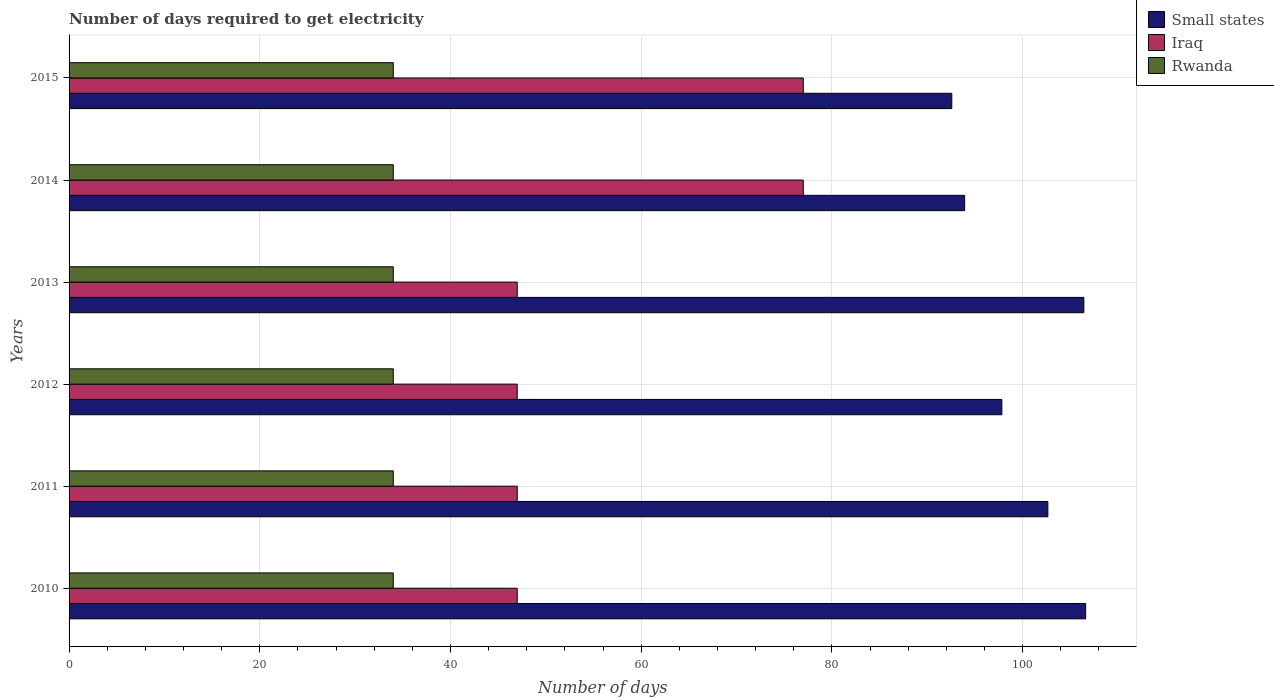Are the number of bars per tick equal to the number of legend labels?
Provide a succinct answer. Yes. Are the number of bars on each tick of the Y-axis equal?
Your answer should be very brief. Yes. What is the label of the 3rd group of bars from the top?
Offer a terse response. 2013. In how many cases, is the number of bars for a given year not equal to the number of legend labels?
Provide a succinct answer. 0. What is the number of days required to get electricity in in Small states in 2015?
Ensure brevity in your answer.  92.58. Across all years, what is the maximum number of days required to get electricity in in Rwanda?
Ensure brevity in your answer.  34. Across all years, what is the minimum number of days required to get electricity in in Rwanda?
Offer a terse response. 34. In which year was the number of days required to get electricity in in Iraq maximum?
Offer a terse response. 2014. What is the total number of days required to get electricity in in Rwanda in the graph?
Your response must be concise. 204. What is the difference between the number of days required to get electricity in in Small states in 2011 and that in 2013?
Provide a short and direct response. -3.77. What is the difference between the number of days required to get electricity in in Rwanda in 2013 and the number of days required to get electricity in in Iraq in 2015?
Your response must be concise. -43. In the year 2011, what is the difference between the number of days required to get electricity in in Iraq and number of days required to get electricity in in Small states?
Your answer should be very brief. -55.65. What is the ratio of the number of days required to get electricity in in Rwanda in 2010 to that in 2013?
Provide a short and direct response. 1. What is the difference between the highest and the second highest number of days required to get electricity in in Small states?
Provide a short and direct response. 0.19. What is the difference between the highest and the lowest number of days required to get electricity in in Iraq?
Make the answer very short. 30. In how many years, is the number of days required to get electricity in in Iraq greater than the average number of days required to get electricity in in Iraq taken over all years?
Your answer should be compact. 2. What does the 1st bar from the top in 2013 represents?
Keep it short and to the point. Rwanda. What does the 3rd bar from the bottom in 2010 represents?
Provide a short and direct response. Rwanda. Is it the case that in every year, the sum of the number of days required to get electricity in in Rwanda and number of days required to get electricity in in Iraq is greater than the number of days required to get electricity in in Small states?
Your answer should be very brief. No. How many years are there in the graph?
Your response must be concise. 6. Are the values on the major ticks of X-axis written in scientific E-notation?
Provide a succinct answer. No. Where does the legend appear in the graph?
Keep it short and to the point. Top right. How many legend labels are there?
Keep it short and to the point. 3. What is the title of the graph?
Your answer should be compact. Number of days required to get electricity. Does "Greece" appear as one of the legend labels in the graph?
Offer a very short reply. No. What is the label or title of the X-axis?
Your answer should be very brief. Number of days. What is the label or title of the Y-axis?
Your answer should be compact. Years. What is the Number of days in Small states in 2010?
Keep it short and to the point. 106.62. What is the Number of days in Iraq in 2010?
Provide a short and direct response. 47. What is the Number of days of Rwanda in 2010?
Offer a terse response. 34. What is the Number of days of Small states in 2011?
Give a very brief answer. 102.65. What is the Number of days in Iraq in 2011?
Your answer should be compact. 47. What is the Number of days of Rwanda in 2011?
Provide a succinct answer. 34. What is the Number of days of Small states in 2012?
Your answer should be compact. 97.83. What is the Number of days of Rwanda in 2012?
Make the answer very short. 34. What is the Number of days in Small states in 2013?
Your answer should be very brief. 106.42. What is the Number of days in Small states in 2014?
Provide a succinct answer. 93.92. What is the Number of days in Iraq in 2014?
Make the answer very short. 77. What is the Number of days of Small states in 2015?
Your response must be concise. 92.58. What is the Number of days of Iraq in 2015?
Your answer should be compact. 77. What is the Number of days of Rwanda in 2015?
Provide a short and direct response. 34. Across all years, what is the maximum Number of days in Small states?
Your answer should be compact. 106.62. Across all years, what is the maximum Number of days in Iraq?
Your answer should be very brief. 77. Across all years, what is the minimum Number of days in Small states?
Your answer should be very brief. 92.58. Across all years, what is the minimum Number of days in Iraq?
Your response must be concise. 47. Across all years, what is the minimum Number of days of Rwanda?
Your answer should be compact. 34. What is the total Number of days of Small states in the graph?
Ensure brevity in your answer.  600.02. What is the total Number of days of Iraq in the graph?
Give a very brief answer. 342. What is the total Number of days in Rwanda in the graph?
Give a very brief answer. 204. What is the difference between the Number of days of Small states in 2010 and that in 2011?
Provide a short and direct response. 3.97. What is the difference between the Number of days in Iraq in 2010 and that in 2011?
Give a very brief answer. 0. What is the difference between the Number of days of Small states in 2010 and that in 2012?
Offer a very short reply. 8.79. What is the difference between the Number of days of Rwanda in 2010 and that in 2012?
Offer a very short reply. 0. What is the difference between the Number of days in Small states in 2010 and that in 2013?
Provide a short and direct response. 0.19. What is the difference between the Number of days of Rwanda in 2010 and that in 2013?
Make the answer very short. 0. What is the difference between the Number of days in Small states in 2010 and that in 2014?
Ensure brevity in your answer.  12.69. What is the difference between the Number of days in Iraq in 2010 and that in 2014?
Offer a very short reply. -30. What is the difference between the Number of days of Rwanda in 2010 and that in 2014?
Provide a short and direct response. 0. What is the difference between the Number of days in Small states in 2010 and that in 2015?
Keep it short and to the point. 14.04. What is the difference between the Number of days in Small states in 2011 and that in 2012?
Provide a short and direct response. 4.83. What is the difference between the Number of days of Small states in 2011 and that in 2013?
Provide a succinct answer. -3.77. What is the difference between the Number of days of Rwanda in 2011 and that in 2013?
Offer a very short reply. 0. What is the difference between the Number of days of Small states in 2011 and that in 2014?
Keep it short and to the point. 8.72. What is the difference between the Number of days of Small states in 2011 and that in 2015?
Give a very brief answer. 10.07. What is the difference between the Number of days of Rwanda in 2011 and that in 2015?
Offer a terse response. 0. What is the difference between the Number of days of Small states in 2012 and that in 2013?
Give a very brief answer. -8.6. What is the difference between the Number of days of Iraq in 2012 and that in 2013?
Ensure brevity in your answer.  0. What is the difference between the Number of days in Rwanda in 2012 and that in 2014?
Provide a succinct answer. 0. What is the difference between the Number of days of Small states in 2012 and that in 2015?
Provide a short and direct response. 5.25. What is the difference between the Number of days of Iraq in 2012 and that in 2015?
Ensure brevity in your answer.  -30. What is the difference between the Number of days of Small states in 2013 and that in 2014?
Offer a terse response. 12.5. What is the difference between the Number of days of Iraq in 2013 and that in 2014?
Give a very brief answer. -30. What is the difference between the Number of days of Small states in 2013 and that in 2015?
Offer a very short reply. 13.85. What is the difference between the Number of days in Small states in 2014 and that in 2015?
Provide a short and direct response. 1.35. What is the difference between the Number of days of Iraq in 2014 and that in 2015?
Keep it short and to the point. 0. What is the difference between the Number of days of Small states in 2010 and the Number of days of Iraq in 2011?
Offer a terse response. 59.62. What is the difference between the Number of days of Small states in 2010 and the Number of days of Rwanda in 2011?
Offer a very short reply. 72.62. What is the difference between the Number of days of Small states in 2010 and the Number of days of Iraq in 2012?
Your answer should be compact. 59.62. What is the difference between the Number of days in Small states in 2010 and the Number of days in Rwanda in 2012?
Provide a succinct answer. 72.62. What is the difference between the Number of days of Iraq in 2010 and the Number of days of Rwanda in 2012?
Provide a short and direct response. 13. What is the difference between the Number of days of Small states in 2010 and the Number of days of Iraq in 2013?
Offer a terse response. 59.62. What is the difference between the Number of days in Small states in 2010 and the Number of days in Rwanda in 2013?
Provide a succinct answer. 72.62. What is the difference between the Number of days in Iraq in 2010 and the Number of days in Rwanda in 2013?
Your answer should be very brief. 13. What is the difference between the Number of days of Small states in 2010 and the Number of days of Iraq in 2014?
Your answer should be very brief. 29.62. What is the difference between the Number of days in Small states in 2010 and the Number of days in Rwanda in 2014?
Ensure brevity in your answer.  72.62. What is the difference between the Number of days of Iraq in 2010 and the Number of days of Rwanda in 2014?
Ensure brevity in your answer.  13. What is the difference between the Number of days of Small states in 2010 and the Number of days of Iraq in 2015?
Give a very brief answer. 29.62. What is the difference between the Number of days of Small states in 2010 and the Number of days of Rwanda in 2015?
Give a very brief answer. 72.62. What is the difference between the Number of days of Small states in 2011 and the Number of days of Iraq in 2012?
Give a very brief answer. 55.65. What is the difference between the Number of days in Small states in 2011 and the Number of days in Rwanda in 2012?
Keep it short and to the point. 68.65. What is the difference between the Number of days of Small states in 2011 and the Number of days of Iraq in 2013?
Offer a terse response. 55.65. What is the difference between the Number of days of Small states in 2011 and the Number of days of Rwanda in 2013?
Give a very brief answer. 68.65. What is the difference between the Number of days in Small states in 2011 and the Number of days in Iraq in 2014?
Keep it short and to the point. 25.65. What is the difference between the Number of days of Small states in 2011 and the Number of days of Rwanda in 2014?
Your answer should be very brief. 68.65. What is the difference between the Number of days in Iraq in 2011 and the Number of days in Rwanda in 2014?
Give a very brief answer. 13. What is the difference between the Number of days of Small states in 2011 and the Number of days of Iraq in 2015?
Make the answer very short. 25.65. What is the difference between the Number of days in Small states in 2011 and the Number of days in Rwanda in 2015?
Provide a short and direct response. 68.65. What is the difference between the Number of days in Iraq in 2011 and the Number of days in Rwanda in 2015?
Offer a very short reply. 13. What is the difference between the Number of days of Small states in 2012 and the Number of days of Iraq in 2013?
Your answer should be compact. 50.83. What is the difference between the Number of days of Small states in 2012 and the Number of days of Rwanda in 2013?
Ensure brevity in your answer.  63.83. What is the difference between the Number of days of Iraq in 2012 and the Number of days of Rwanda in 2013?
Give a very brief answer. 13. What is the difference between the Number of days of Small states in 2012 and the Number of days of Iraq in 2014?
Make the answer very short. 20.82. What is the difference between the Number of days of Small states in 2012 and the Number of days of Rwanda in 2014?
Your response must be concise. 63.83. What is the difference between the Number of days of Iraq in 2012 and the Number of days of Rwanda in 2014?
Offer a terse response. 13. What is the difference between the Number of days of Small states in 2012 and the Number of days of Iraq in 2015?
Your response must be concise. 20.82. What is the difference between the Number of days in Small states in 2012 and the Number of days in Rwanda in 2015?
Your answer should be compact. 63.83. What is the difference between the Number of days in Iraq in 2012 and the Number of days in Rwanda in 2015?
Make the answer very short. 13. What is the difference between the Number of days of Small states in 2013 and the Number of days of Iraq in 2014?
Provide a succinct answer. 29.43. What is the difference between the Number of days of Small states in 2013 and the Number of days of Rwanda in 2014?
Ensure brevity in your answer.  72.42. What is the difference between the Number of days in Iraq in 2013 and the Number of days in Rwanda in 2014?
Your answer should be compact. 13. What is the difference between the Number of days of Small states in 2013 and the Number of days of Iraq in 2015?
Your answer should be very brief. 29.43. What is the difference between the Number of days in Small states in 2013 and the Number of days in Rwanda in 2015?
Ensure brevity in your answer.  72.42. What is the difference between the Number of days in Iraq in 2013 and the Number of days in Rwanda in 2015?
Your answer should be compact. 13. What is the difference between the Number of days of Small states in 2014 and the Number of days of Iraq in 2015?
Provide a succinct answer. 16.93. What is the difference between the Number of days of Small states in 2014 and the Number of days of Rwanda in 2015?
Offer a very short reply. 59.92. What is the difference between the Number of days in Iraq in 2014 and the Number of days in Rwanda in 2015?
Your answer should be very brief. 43. What is the average Number of days in Small states per year?
Your answer should be compact. 100. In the year 2010, what is the difference between the Number of days of Small states and Number of days of Iraq?
Ensure brevity in your answer.  59.62. In the year 2010, what is the difference between the Number of days of Small states and Number of days of Rwanda?
Keep it short and to the point. 72.62. In the year 2010, what is the difference between the Number of days of Iraq and Number of days of Rwanda?
Your answer should be compact. 13. In the year 2011, what is the difference between the Number of days in Small states and Number of days in Iraq?
Your answer should be compact. 55.65. In the year 2011, what is the difference between the Number of days in Small states and Number of days in Rwanda?
Make the answer very short. 68.65. In the year 2011, what is the difference between the Number of days in Iraq and Number of days in Rwanda?
Provide a short and direct response. 13. In the year 2012, what is the difference between the Number of days in Small states and Number of days in Iraq?
Your response must be concise. 50.83. In the year 2012, what is the difference between the Number of days in Small states and Number of days in Rwanda?
Keep it short and to the point. 63.83. In the year 2012, what is the difference between the Number of days in Iraq and Number of days in Rwanda?
Keep it short and to the point. 13. In the year 2013, what is the difference between the Number of days in Small states and Number of days in Iraq?
Make the answer very short. 59.42. In the year 2013, what is the difference between the Number of days in Small states and Number of days in Rwanda?
Offer a very short reply. 72.42. In the year 2013, what is the difference between the Number of days in Iraq and Number of days in Rwanda?
Provide a short and direct response. 13. In the year 2014, what is the difference between the Number of days in Small states and Number of days in Iraq?
Your answer should be compact. 16.93. In the year 2014, what is the difference between the Number of days in Small states and Number of days in Rwanda?
Make the answer very short. 59.92. In the year 2015, what is the difference between the Number of days in Small states and Number of days in Iraq?
Provide a succinct answer. 15.57. In the year 2015, what is the difference between the Number of days of Small states and Number of days of Rwanda?
Ensure brevity in your answer.  58.58. In the year 2015, what is the difference between the Number of days of Iraq and Number of days of Rwanda?
Ensure brevity in your answer.  43. What is the ratio of the Number of days of Small states in 2010 to that in 2011?
Make the answer very short. 1.04. What is the ratio of the Number of days in Small states in 2010 to that in 2012?
Offer a terse response. 1.09. What is the ratio of the Number of days in Iraq in 2010 to that in 2012?
Your answer should be compact. 1. What is the ratio of the Number of days of Iraq in 2010 to that in 2013?
Your answer should be compact. 1. What is the ratio of the Number of days in Rwanda in 2010 to that in 2013?
Keep it short and to the point. 1. What is the ratio of the Number of days in Small states in 2010 to that in 2014?
Provide a short and direct response. 1.14. What is the ratio of the Number of days in Iraq in 2010 to that in 2014?
Make the answer very short. 0.61. What is the ratio of the Number of days of Small states in 2010 to that in 2015?
Offer a very short reply. 1.15. What is the ratio of the Number of days in Iraq in 2010 to that in 2015?
Your response must be concise. 0.61. What is the ratio of the Number of days of Small states in 2011 to that in 2012?
Offer a very short reply. 1.05. What is the ratio of the Number of days in Rwanda in 2011 to that in 2012?
Your response must be concise. 1. What is the ratio of the Number of days of Small states in 2011 to that in 2013?
Keep it short and to the point. 0.96. What is the ratio of the Number of days in Iraq in 2011 to that in 2013?
Give a very brief answer. 1. What is the ratio of the Number of days of Small states in 2011 to that in 2014?
Your answer should be compact. 1.09. What is the ratio of the Number of days of Iraq in 2011 to that in 2014?
Give a very brief answer. 0.61. What is the ratio of the Number of days of Rwanda in 2011 to that in 2014?
Offer a very short reply. 1. What is the ratio of the Number of days of Small states in 2011 to that in 2015?
Give a very brief answer. 1.11. What is the ratio of the Number of days of Iraq in 2011 to that in 2015?
Offer a terse response. 0.61. What is the ratio of the Number of days of Rwanda in 2011 to that in 2015?
Keep it short and to the point. 1. What is the ratio of the Number of days in Small states in 2012 to that in 2013?
Your answer should be very brief. 0.92. What is the ratio of the Number of days in Iraq in 2012 to that in 2013?
Offer a very short reply. 1. What is the ratio of the Number of days in Small states in 2012 to that in 2014?
Your response must be concise. 1.04. What is the ratio of the Number of days of Iraq in 2012 to that in 2014?
Offer a terse response. 0.61. What is the ratio of the Number of days of Rwanda in 2012 to that in 2014?
Offer a terse response. 1. What is the ratio of the Number of days of Small states in 2012 to that in 2015?
Offer a very short reply. 1.06. What is the ratio of the Number of days in Iraq in 2012 to that in 2015?
Make the answer very short. 0.61. What is the ratio of the Number of days of Small states in 2013 to that in 2014?
Your answer should be compact. 1.13. What is the ratio of the Number of days of Iraq in 2013 to that in 2014?
Provide a succinct answer. 0.61. What is the ratio of the Number of days in Rwanda in 2013 to that in 2014?
Your answer should be compact. 1. What is the ratio of the Number of days of Small states in 2013 to that in 2015?
Keep it short and to the point. 1.15. What is the ratio of the Number of days in Iraq in 2013 to that in 2015?
Your answer should be compact. 0.61. What is the ratio of the Number of days in Small states in 2014 to that in 2015?
Offer a very short reply. 1.01. What is the difference between the highest and the second highest Number of days in Small states?
Your response must be concise. 0.19. What is the difference between the highest and the second highest Number of days of Iraq?
Your answer should be compact. 0. What is the difference between the highest and the lowest Number of days in Small states?
Your answer should be very brief. 14.04. 